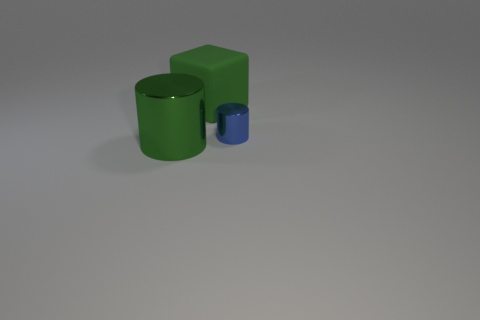What is the size of the shiny cylinder that is right of the large block?
Provide a short and direct response. Small. What shape is the object that is made of the same material as the small blue cylinder?
Offer a terse response. Cylinder. Is the block made of the same material as the green thing that is in front of the large green rubber block?
Keep it short and to the point. No. There is a large green object in front of the small shiny cylinder; is its shape the same as the tiny shiny thing?
Offer a very short reply. Yes. Do the tiny blue metal thing and the big green object on the right side of the big metallic object have the same shape?
Your response must be concise. No. What is the color of the object that is both behind the big green cylinder and in front of the large rubber cube?
Ensure brevity in your answer.  Blue. Is there a tiny purple matte ball?
Your response must be concise. No. Are there an equal number of metal objects behind the large cylinder and small things?
Your response must be concise. Yes. What number of other objects are there of the same shape as the rubber thing?
Your answer should be very brief. 0. What is the shape of the small object?
Give a very brief answer. Cylinder. 